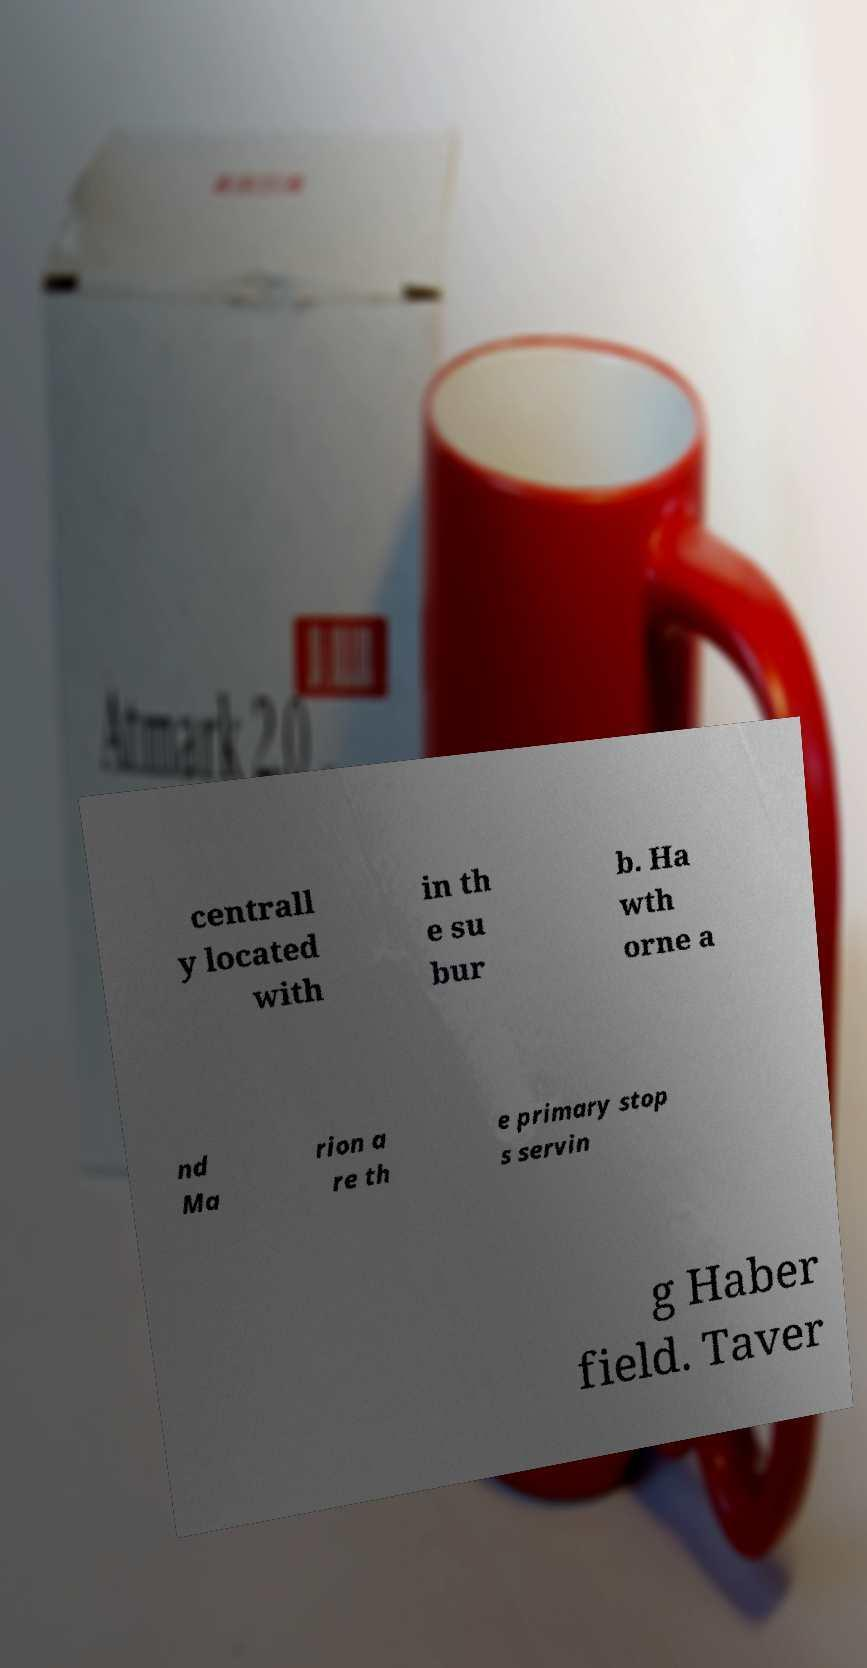There's text embedded in this image that I need extracted. Can you transcribe it verbatim? centrall y located with in th e su bur b. Ha wth orne a nd Ma rion a re th e primary stop s servin g Haber field. Taver 